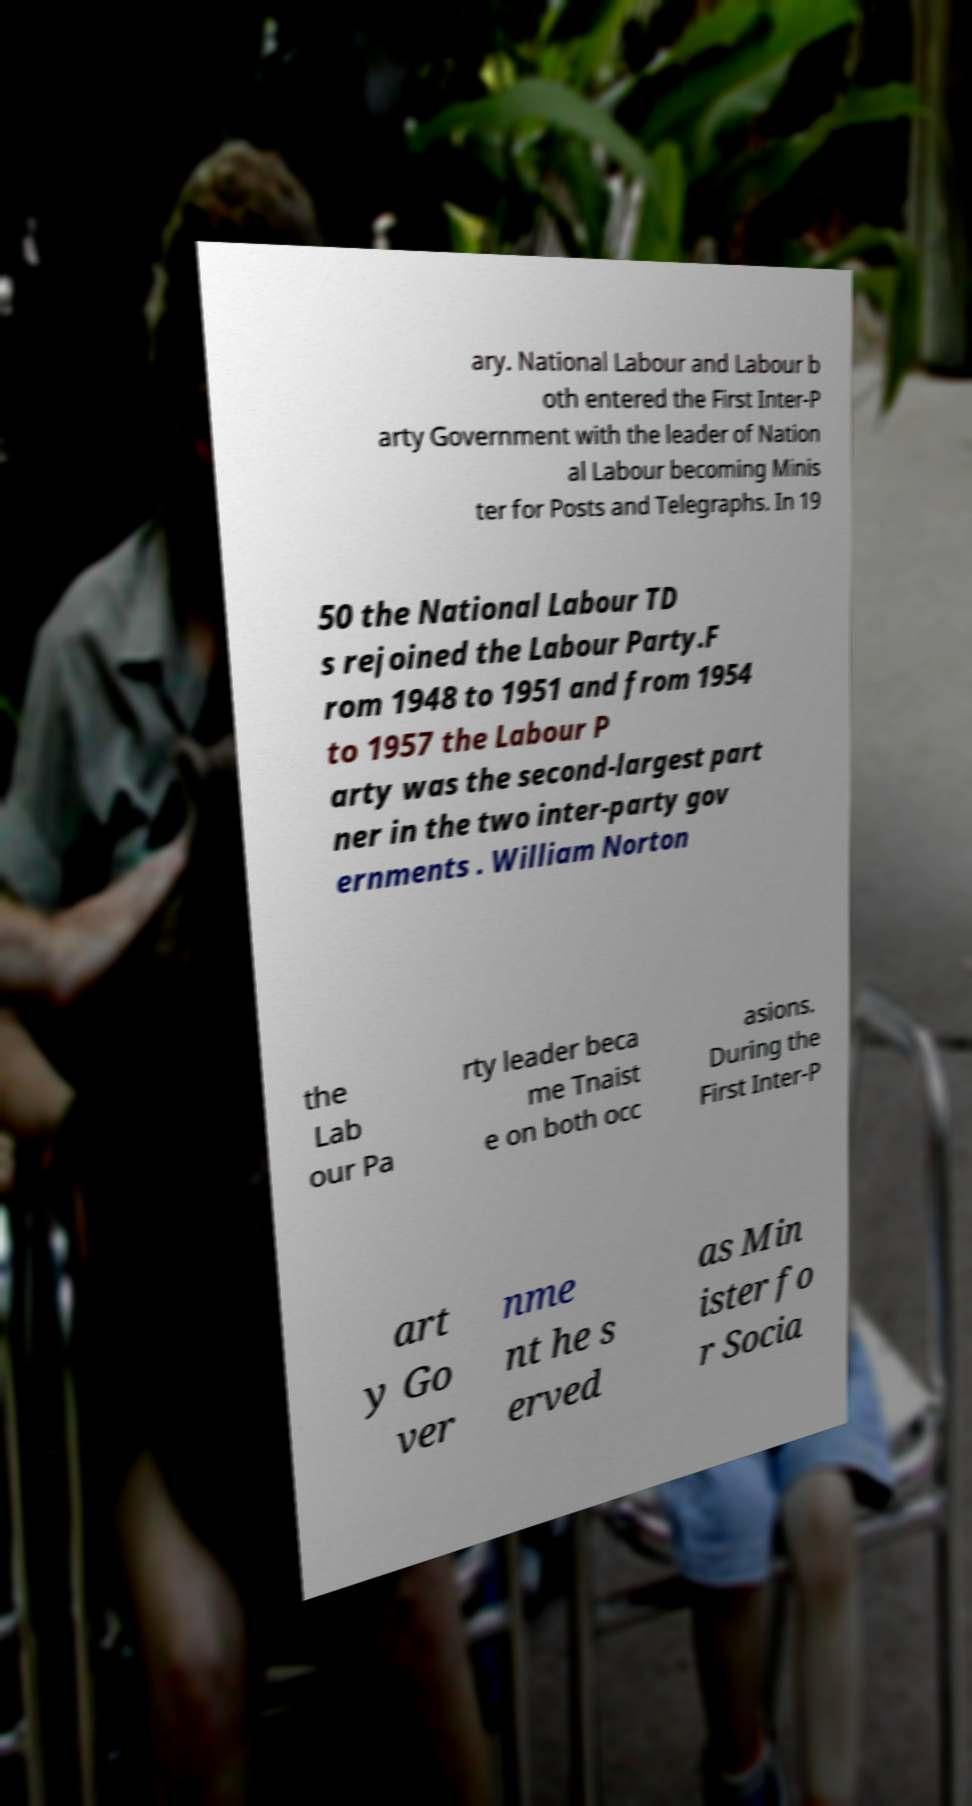What messages or text are displayed in this image? I need them in a readable, typed format. ary. National Labour and Labour b oth entered the First Inter-P arty Government with the leader of Nation al Labour becoming Minis ter for Posts and Telegraphs. In 19 50 the National Labour TD s rejoined the Labour Party.F rom 1948 to 1951 and from 1954 to 1957 the Labour P arty was the second-largest part ner in the two inter-party gov ernments . William Norton the Lab our Pa rty leader beca me Tnaist e on both occ asions. During the First Inter-P art y Go ver nme nt he s erved as Min ister fo r Socia 